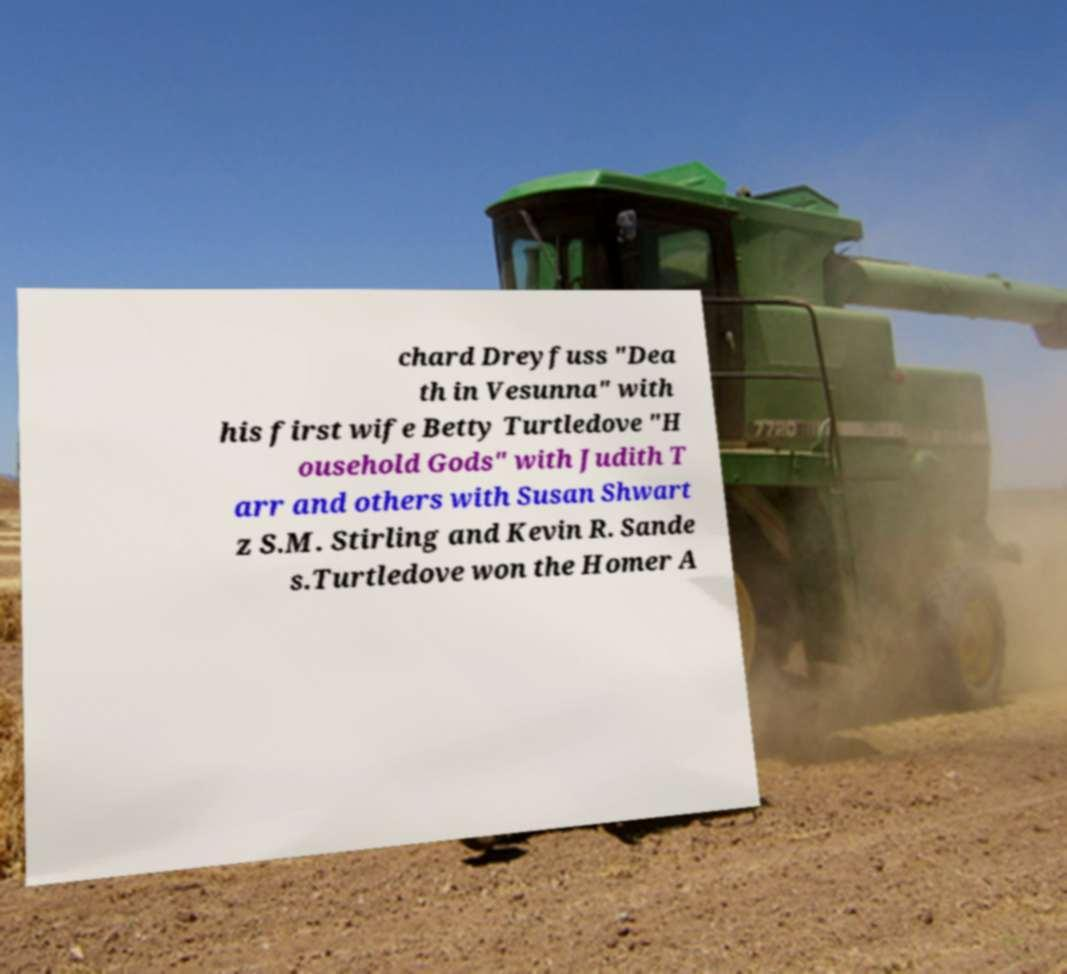Please identify and transcribe the text found in this image. chard Dreyfuss "Dea th in Vesunna" with his first wife Betty Turtledove "H ousehold Gods" with Judith T arr and others with Susan Shwart z S.M. Stirling and Kevin R. Sande s.Turtledove won the Homer A 